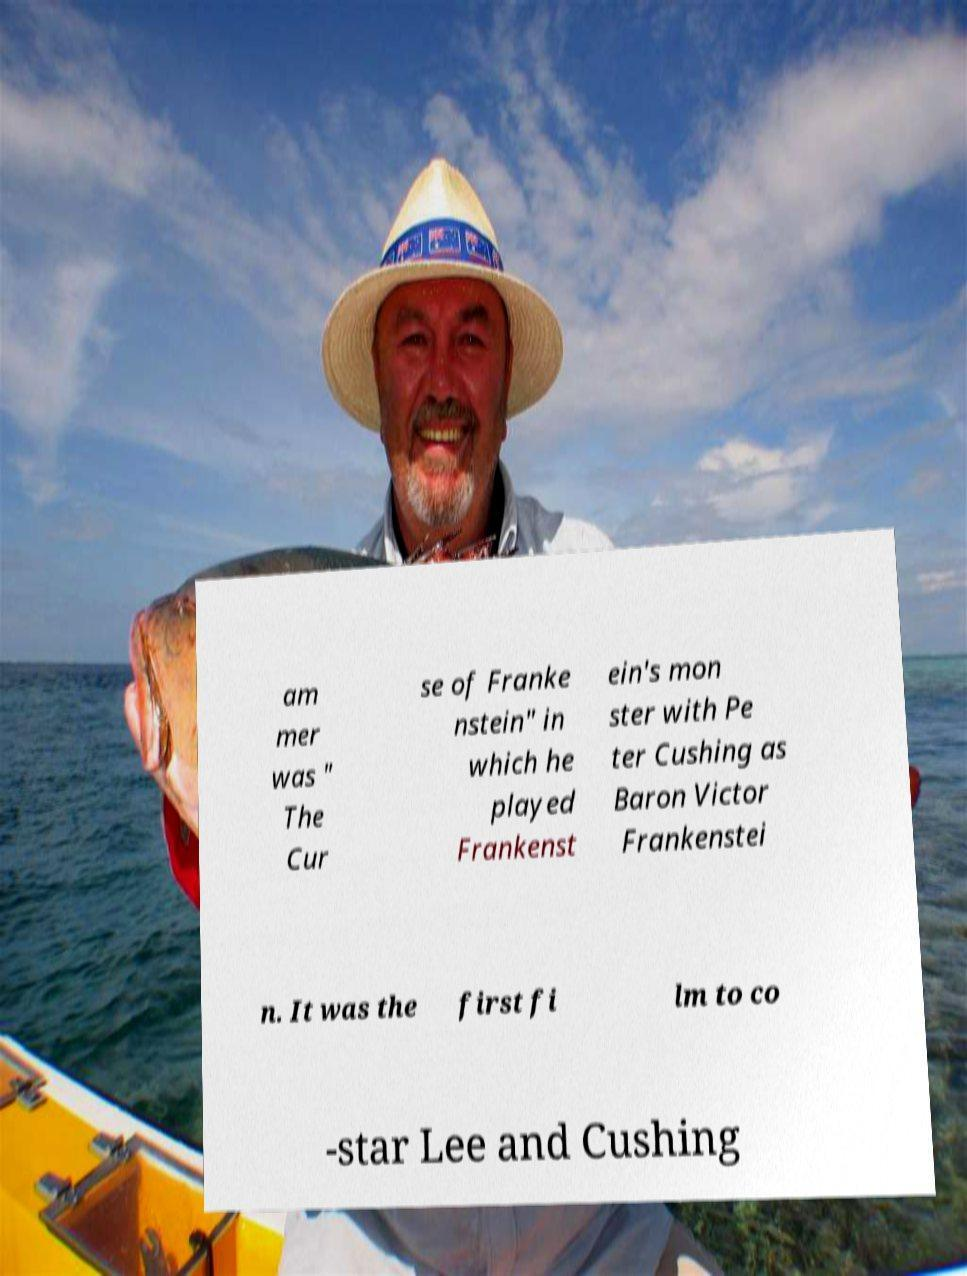Can you read and provide the text displayed in the image?This photo seems to have some interesting text. Can you extract and type it out for me? am mer was " The Cur se of Franke nstein" in which he played Frankenst ein's mon ster with Pe ter Cushing as Baron Victor Frankenstei n. It was the first fi lm to co -star Lee and Cushing 